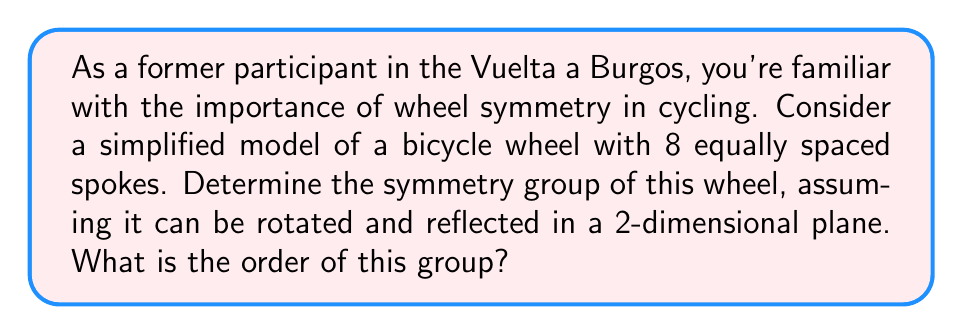Solve this math problem. To determine the symmetry group of the bicycle wheel, we need to consider all the transformations that leave the wheel unchanged. Let's approach this step-by-step:

1) Rotational symmetries:
   The wheel can be rotated by multiples of 45° (360° / 8) and remain unchanged.
   There are 8 distinct rotations: 0°, 45°, 90°, 135°, 180°, 225°, 270°, and 315°.

2) Reflection symmetries:
   The wheel has 8 lines of reflection:
   - 4 lines passing through opposite spokes
   - 4 lines passing between adjacent spokes

3) The symmetry group of this wheel is known as the dihedral group $D_8$.

4) The elements of $D_8$ can be represented as:
   $$D_8 = \{e, r, r^2, r^3, r^4, r^5, r^6, r^7, s, sr, sr^2, sr^3, sr^4, sr^5, sr^6, sr^7\}$$
   where $e$ is the identity, $r$ is a rotation by 45°, and $s$ is a reflection.

5) To determine the order of the group, we count the number of elements:
   - 8 rotations (including the identity)
   - 8 reflections

6) Therefore, the order of the group is 8 + 8 = 16.

The symmetry group $D_8$ is isomorphic to the group of rigid motions of a regular octagon, which matches our 8-spoked wheel model.
Answer: The symmetry group of the 8-spoked bicycle wheel is the dihedral group $D_8$, which has order 16. 